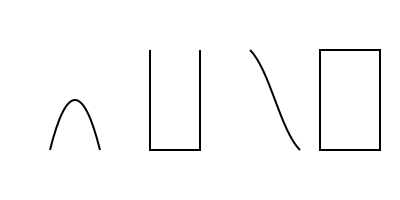As a local musician collaborating with a traveling artist, you need to quickly identify instruments for a fusion performance. Which of the silhouettes above represents a piano? To identify the piano silhouette, let's analyze each shape:

1. The first silhouette (leftmost) shows a curved shape, resembling a harp or lyre.
2. The second silhouette is a rectangular shape with straight lines, characteristic of a piano's side view.
3. The third silhouette has a curved shape, similar to a saxophone or other wind instrument.
4. The fourth silhouette (rightmost) is a trapezoidal shape, which could represent an accordion or a small keyboard.

The piano is known for its distinctive rectangular shape when viewed from the side, which includes the body of the instrument and the straight line of the keys. This matches the second silhouette in the image.
Answer: Second silhouette from the left 